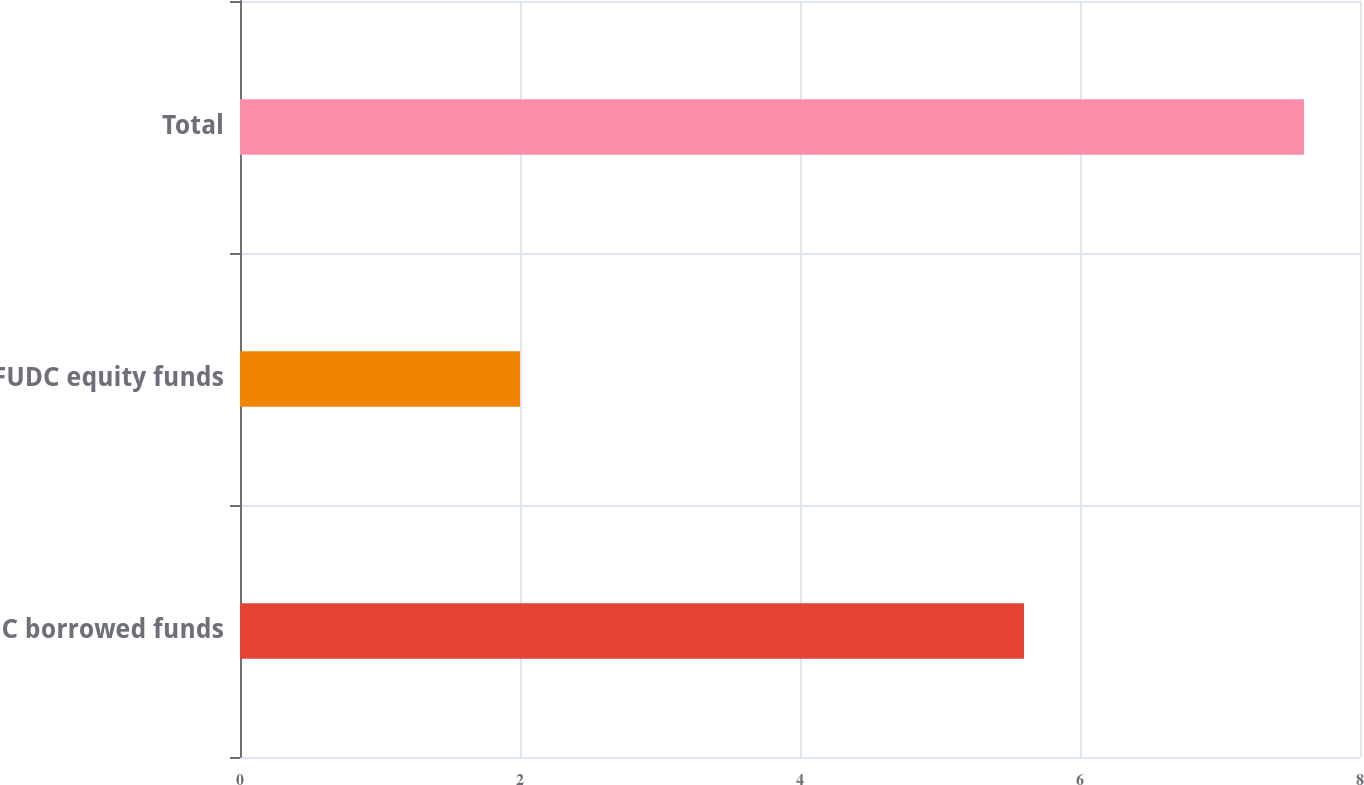Convert chart to OTSL. <chart><loc_0><loc_0><loc_500><loc_500><bar_chart><fcel>AFUDC borrowed funds<fcel>AFUDC equity funds<fcel>Total<nl><fcel>5.6<fcel>2<fcel>7.6<nl></chart> 